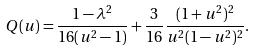Convert formula to latex. <formula><loc_0><loc_0><loc_500><loc_500>Q ( u ) = \frac { 1 - \lambda ^ { 2 } } { 1 6 ( u ^ { 2 } - 1 ) } + \frac { 3 } { 1 6 } \frac { ( 1 + u ^ { 2 } ) ^ { 2 } } { u ^ { 2 } ( 1 - u ^ { 2 } ) ^ { 2 } } .</formula> 